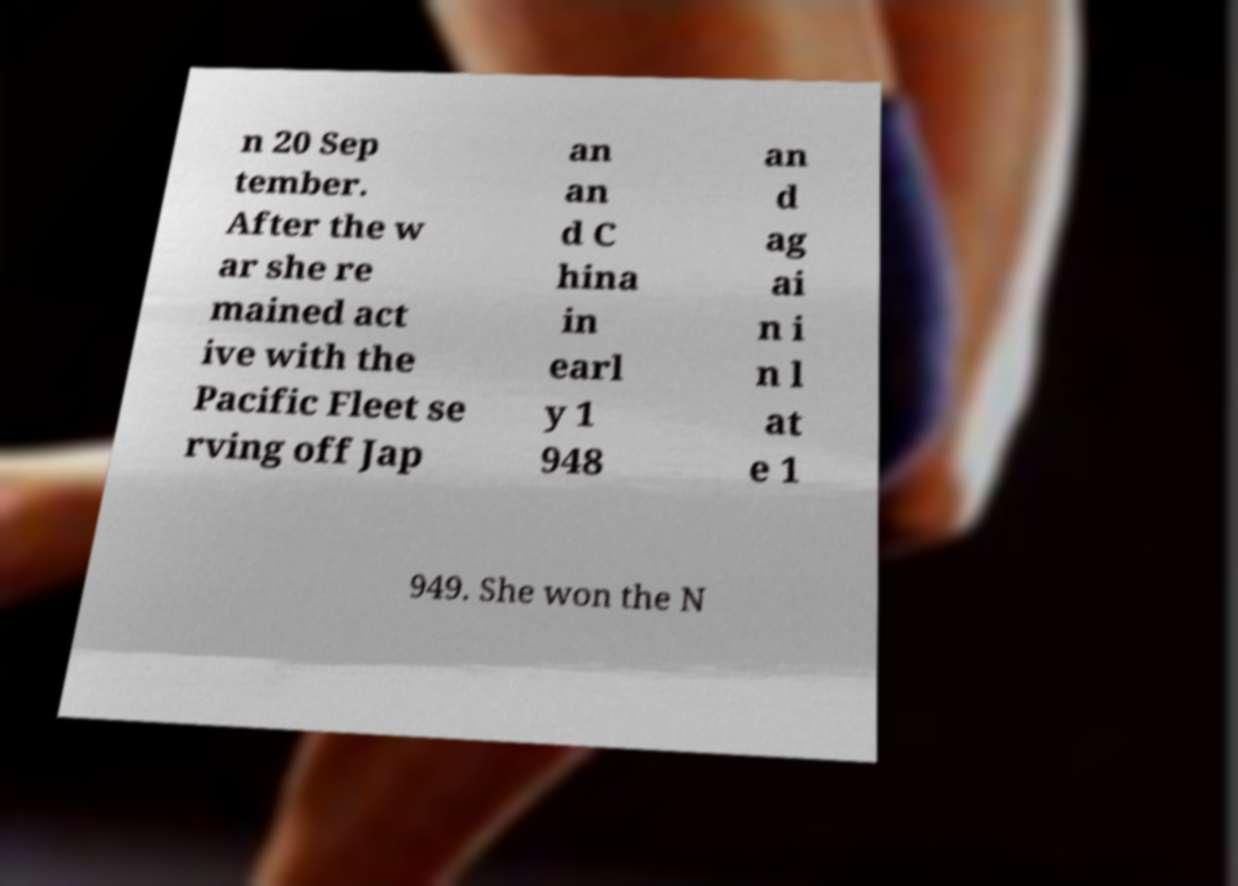Could you extract and type out the text from this image? n 20 Sep tember. After the w ar she re mained act ive with the Pacific Fleet se rving off Jap an an d C hina in earl y 1 948 an d ag ai n i n l at e 1 949. She won the N 